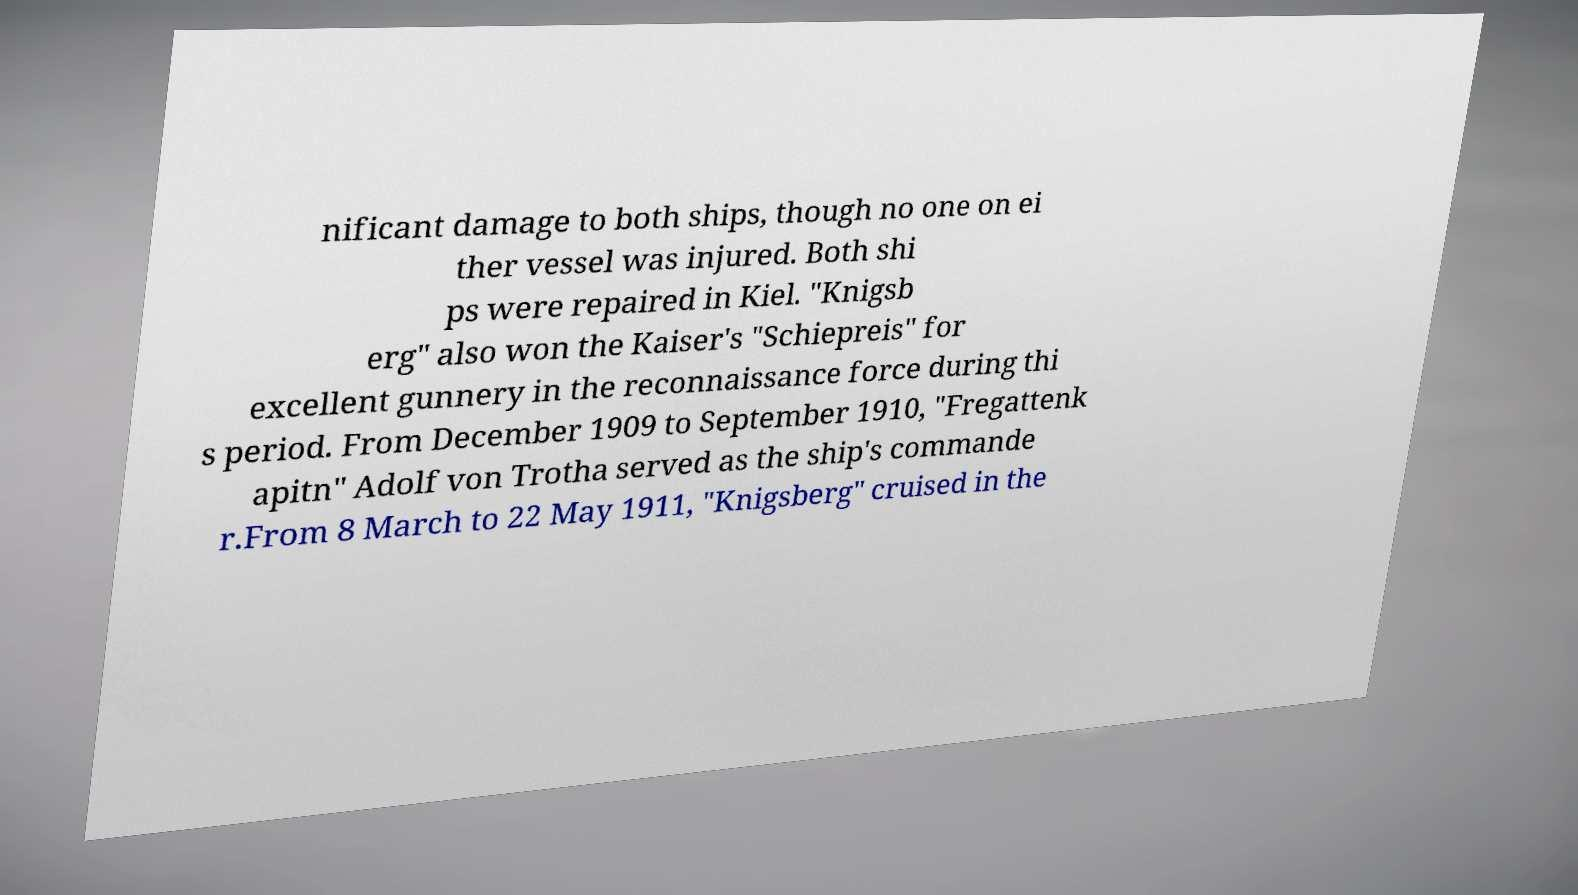Could you assist in decoding the text presented in this image and type it out clearly? nificant damage to both ships, though no one on ei ther vessel was injured. Both shi ps were repaired in Kiel. "Knigsb erg" also won the Kaiser's "Schiepreis" for excellent gunnery in the reconnaissance force during thi s period. From December 1909 to September 1910, "Fregattenk apitn" Adolf von Trotha served as the ship's commande r.From 8 March to 22 May 1911, "Knigsberg" cruised in the 